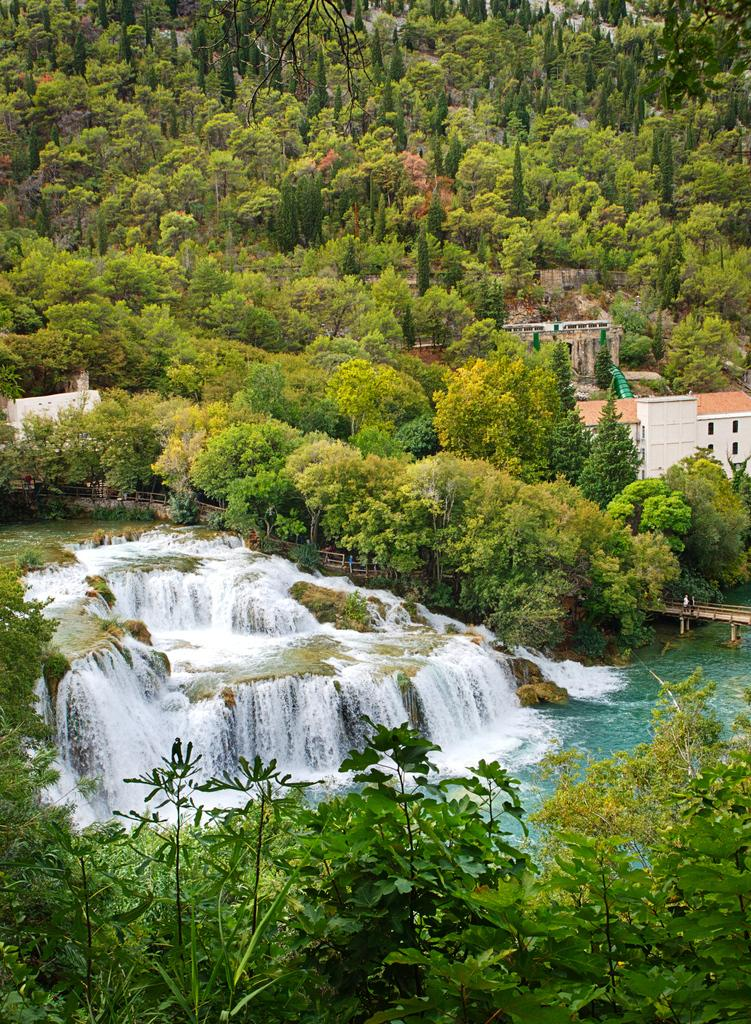What type of natural elements can be seen in the image? There are trees in the image. What type of man-made structures are present in the image? There are buildings in the image. What is the water in the image doing? Water is flowing in the image. What connects the two sides of the water in the image? There is a bridge in the image. Are there any people in the image? Yes, there are people standing on the bridge. What type of plastic material can be seen covering the trees in the image? There is no plastic material covering the trees in the image. Is it raining in the image? The provided facts do not mention any rain in the image. 